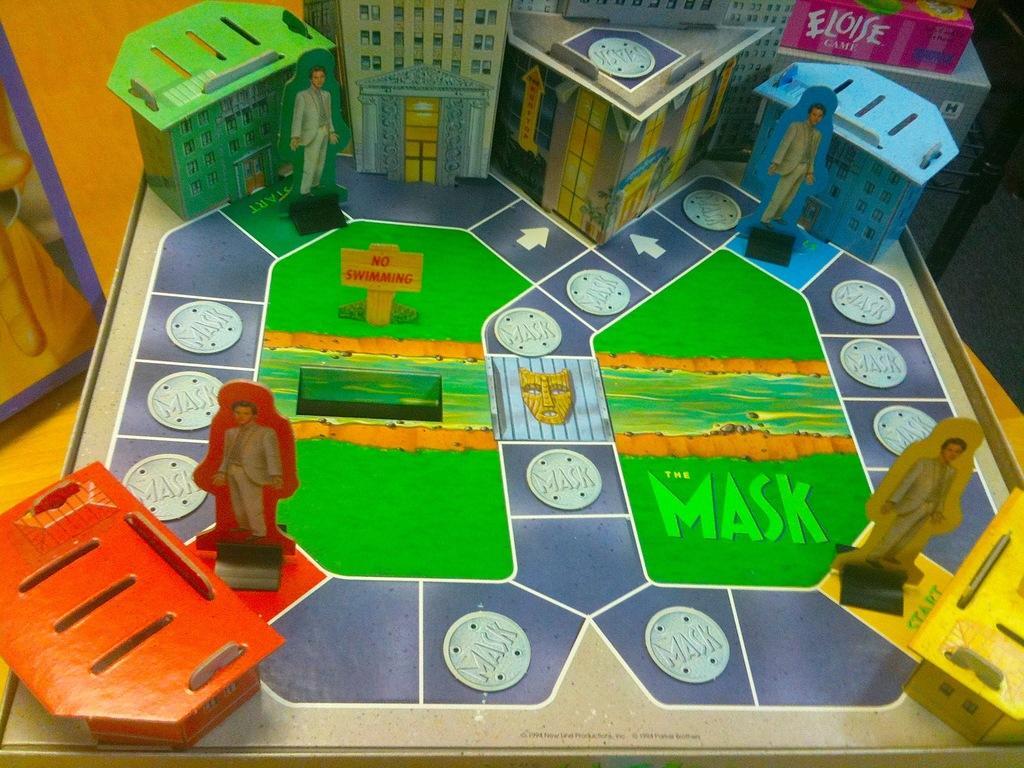Describe this image in one or two sentences. In this image, we can see a game board. 